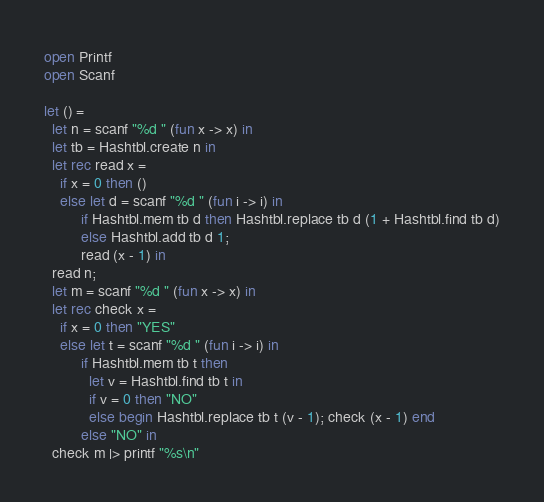<code> <loc_0><loc_0><loc_500><loc_500><_OCaml_>open Printf
open Scanf

let () =
  let n = scanf "%d " (fun x -> x) in
  let tb = Hashtbl.create n in
  let rec read x =
    if x = 0 then ()
    else let d = scanf "%d " (fun i -> i) in
         if Hashtbl.mem tb d then Hashtbl.replace tb d (1 + Hashtbl.find tb d)
         else Hashtbl.add tb d 1;
         read (x - 1) in
  read n;
  let m = scanf "%d " (fun x -> x) in
  let rec check x =
    if x = 0 then "YES"
    else let t = scanf "%d " (fun i -> i) in
         if Hashtbl.mem tb t then
           let v = Hashtbl.find tb t in
           if v = 0 then "NO"
           else begin Hashtbl.replace tb t (v - 1); check (x - 1) end
         else "NO" in
  check m |> printf "%s\n"
</code> 